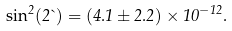Convert formula to latex. <formula><loc_0><loc_0><loc_500><loc_500>\sin ^ { 2 } ( 2 \theta ) = ( 4 . 1 \pm 2 . 2 ) \times 1 0 ^ { - 1 2 } .</formula> 